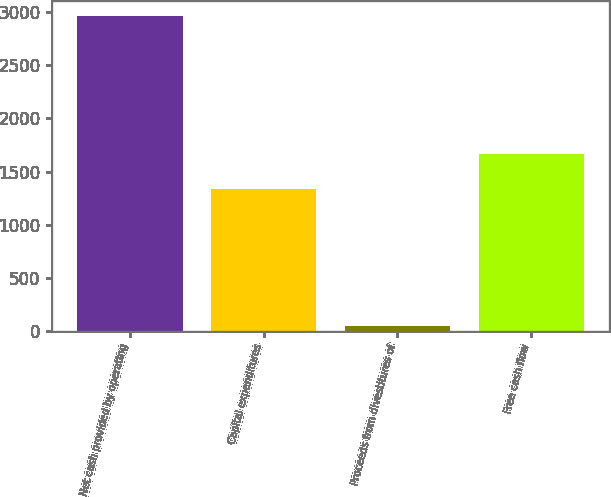Convert chart to OTSL. <chart><loc_0><loc_0><loc_500><loc_500><bar_chart><fcel>Net cash provided by operating<fcel>Capital expenditures<fcel>Proceeds from divestitures of<fcel>Free cash flow<nl><fcel>2960<fcel>1339<fcel>43<fcel>1664<nl></chart> 